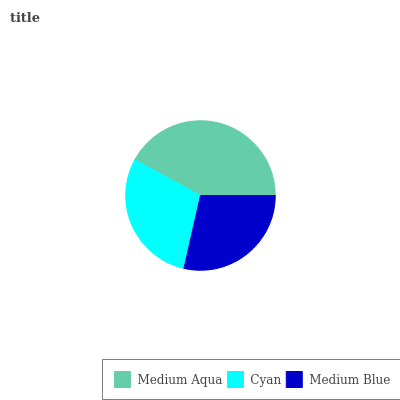Is Medium Blue the minimum?
Answer yes or no. Yes. Is Medium Aqua the maximum?
Answer yes or no. Yes. Is Cyan the minimum?
Answer yes or no. No. Is Cyan the maximum?
Answer yes or no. No. Is Medium Aqua greater than Cyan?
Answer yes or no. Yes. Is Cyan less than Medium Aqua?
Answer yes or no. Yes. Is Cyan greater than Medium Aqua?
Answer yes or no. No. Is Medium Aqua less than Cyan?
Answer yes or no. No. Is Cyan the high median?
Answer yes or no. Yes. Is Cyan the low median?
Answer yes or no. Yes. Is Medium Blue the high median?
Answer yes or no. No. Is Medium Aqua the low median?
Answer yes or no. No. 